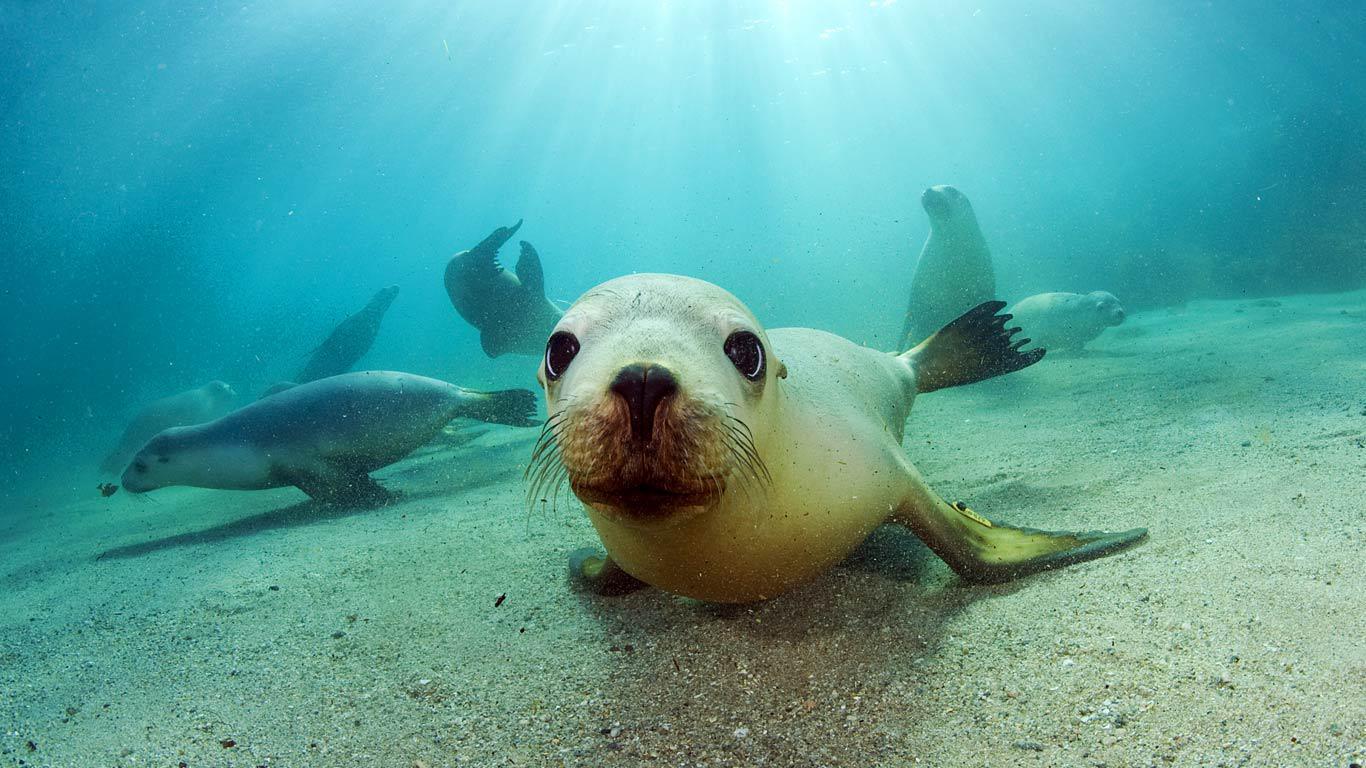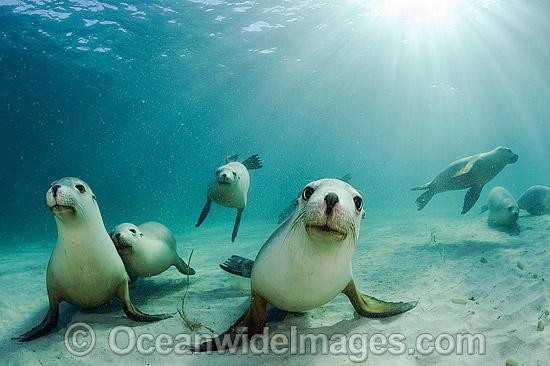The first image is the image on the left, the second image is the image on the right. For the images shown, is this caption "There are more than three seals in the water in the image on the right." true? Answer yes or no. Yes. The first image is the image on the left, the second image is the image on the right. Evaluate the accuracy of this statement regarding the images: "There is no more than two seals in the right image.". Is it true? Answer yes or no. No. 